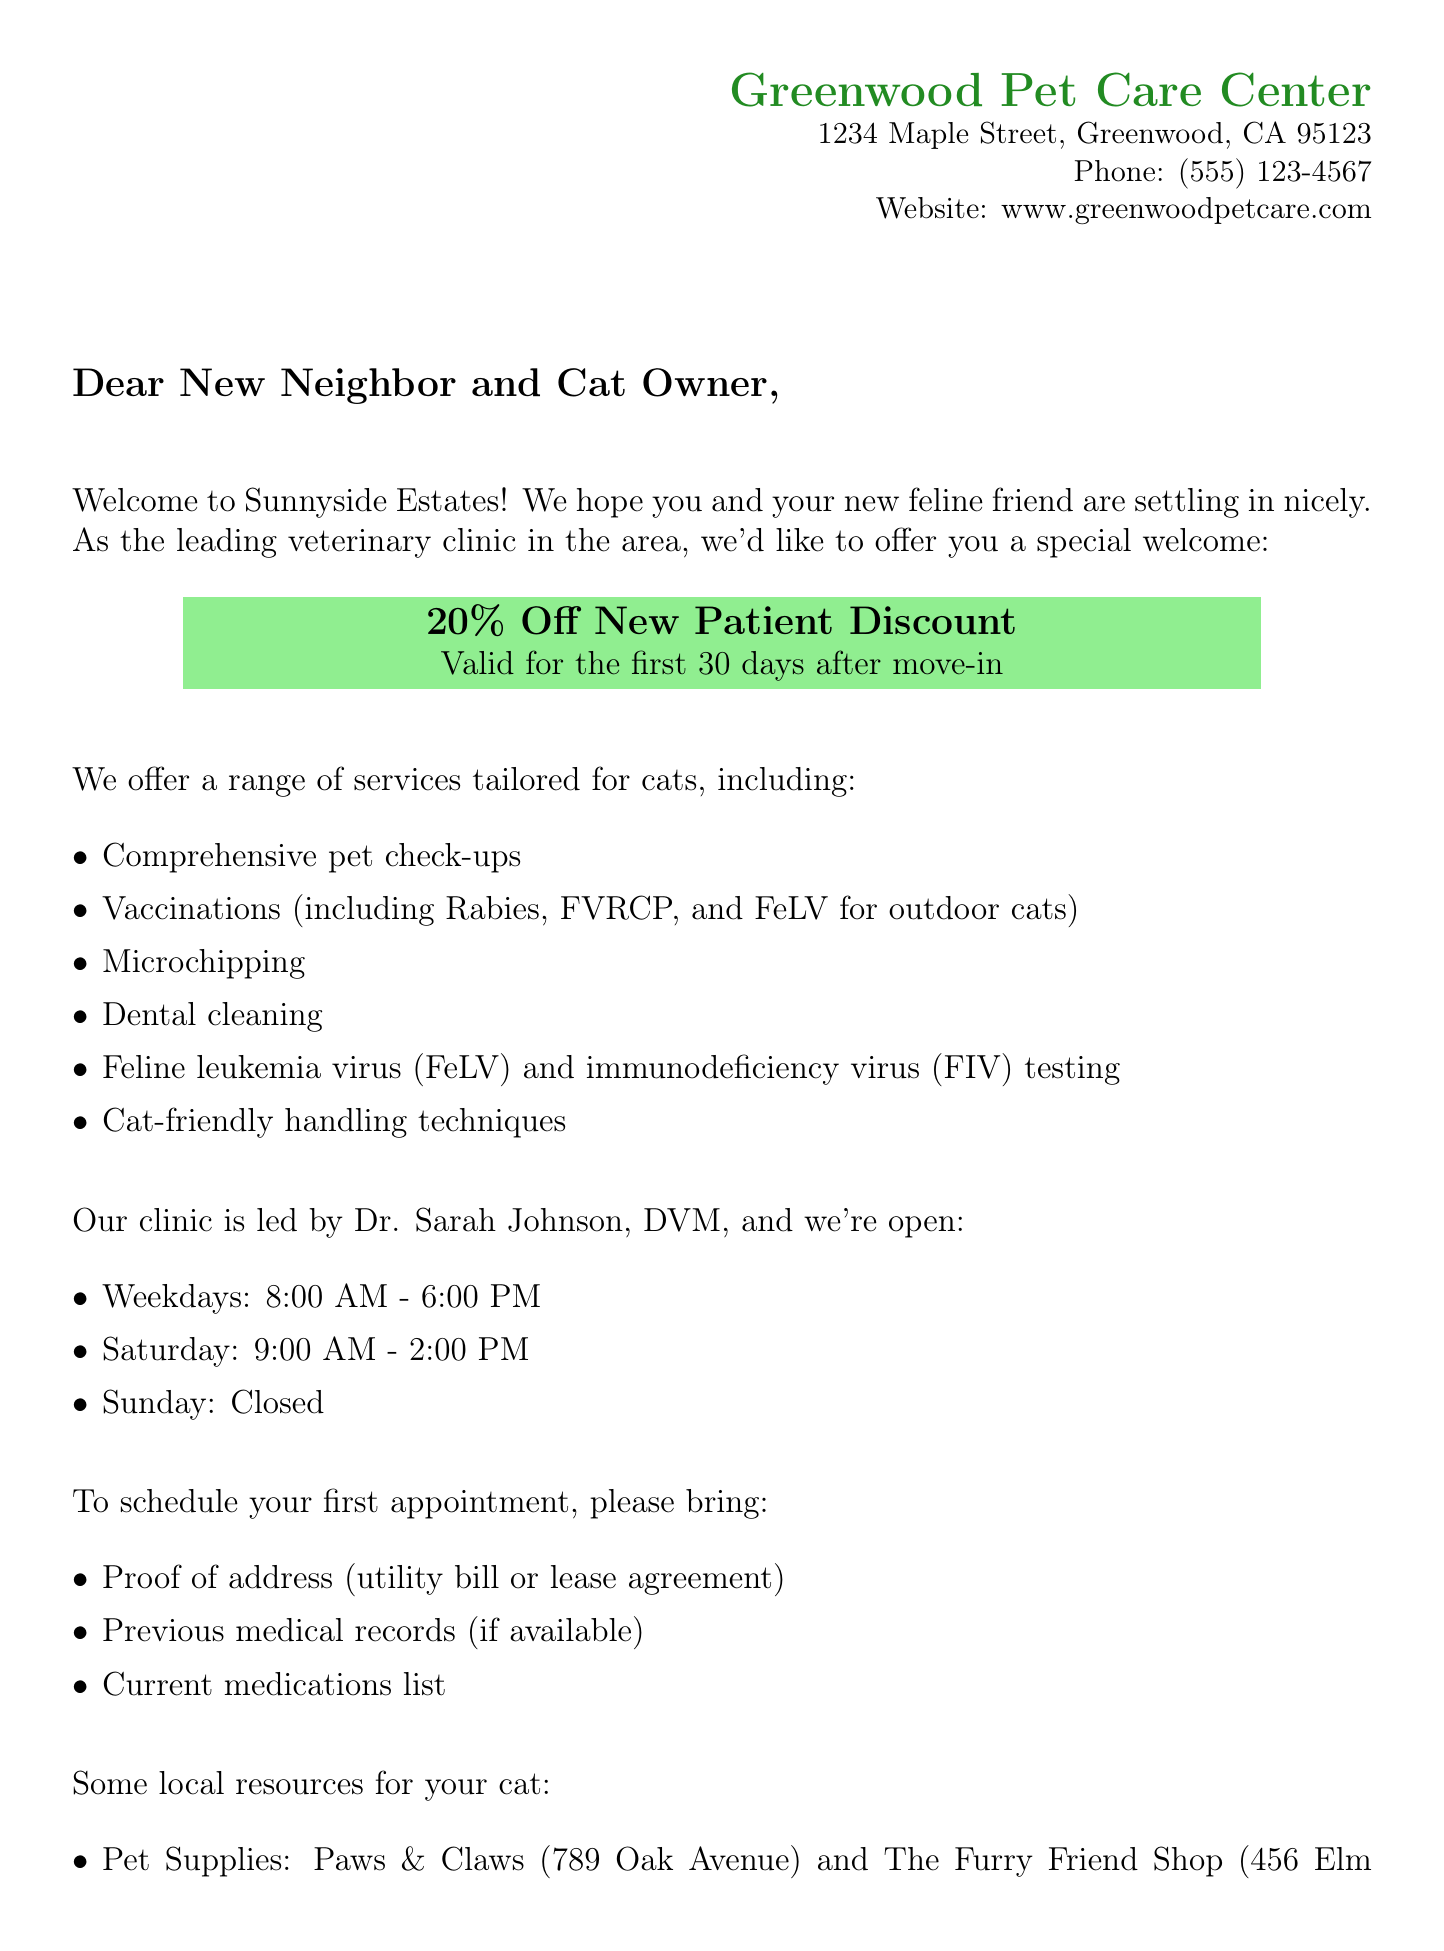What is the name of the clinic? The clinic's name is provided at the top of the document as “Greenwood Pet Care Center.”
Answer: Greenwood Pet Care Center What is the discount percentage for new patients? The document states the discount percentage as “20% Off” for new patient services.
Answer: 20% What are the clinic's hours on weekdays? The document specifies that the clinic is open from “8:00 AM - 6:00 PM” on weekdays.
Answer: 8:00 AM - 6:00 PM What proof is required to become a new patient? The document lists “Proof of address (utility bill or lease agreement)” as one of the requirements for new patients.
Answer: Proof of address What type of testing is specifically mentioned for cats? The document mentions “Feline leukemia virus (FeLV) testing” as a specific service offered for cats.
Answer: Feline leukemia virus (FeLV) testing What is the address of the emergency pet hospital? The document provides the address as “5678 Pine Road, Greenwood, CA 95124” for emergency veterinary services.
Answer: 5678 Pine Road, Greenwood, CA 95124 Which holiday is the Annual Pet Fair scheduled? The document specifies the date of the Annual Pet Fair as “June 15, 2023.”
Answer: June 15, 2023 Who is the leading veterinarian at the clinic? The document states that “Dr. Sarah Johnson, DVM” is the veterinarian leading the clinic.
Answer: Dr. Sarah Johnson, DVM What is the location of the low-cost microchipping clinic? The document mentions that the low-cost microchipping clinic will be at “Greenwood Pet Care Center.”
Answer: Greenwood Pet Care Center 